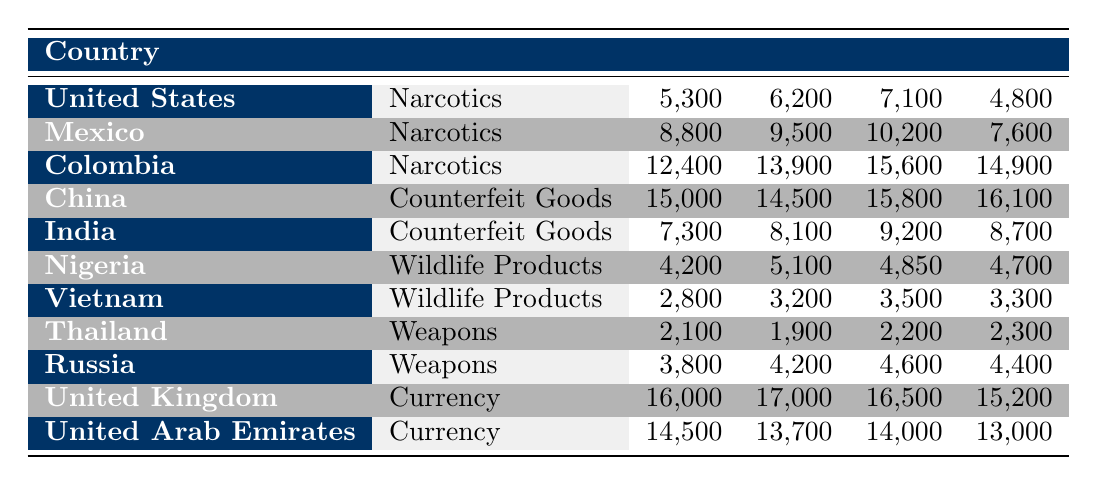What is the total amount of narcotics seized from Colombia in 2022? To find the total amount of narcotics seized from Colombia, I need to sum all quarterly values: 12400 + 13900 + 15600 + 14900 = 56800.
Answer: 56800 Which country seized the most counterfeit goods in Quarter 3? Looking at the Quarter 3 column, China has the highest value at 15800 compared to India's 9200.
Answer: China Is the amount of wildlife products seized from Vietnam greater than that from Nigeria in Quarter 2? In Quarter 2, Vietnam had 3200 and Nigeria had 5100. Since 3200 is less than 5100, the statement is false.
Answer: No What is the average amount of currency seized from the United Kingdom in 2022? To calculate the average for the United Kingdom, I sum the quarterly amounts: 16000 + 17000 + 16500 + 15200 = 64700, then divide by 4 to get 64700 / 4 = 16175.
Answer: 16175 Which type of contraband had the least amount seized in Quarter 1? I can compare the Quarter 1 values across all types: Narcotics (5,300), Counterfeit Goods (15,000), Wildlife Products (4,200), Weapons (2,100), Currency (16,000). The least is 2,100 from Weapons.
Answer: Weapons How much more narcotics were seized from Mexico compared to the United States in Quarter 4? In Quarter 4, Mexico had 7,600 and the United States had 4,800. The difference is 7,600 - 4,800 = 2,800.
Answer: 2800 Did the total amount of weapons seized from Russia exceed that of Thailand in 2022? Total for Russia is 3800 + 4200 + 4600 + 4400 = 17000, and for Thailand it is 2100 + 1900 + 2200 + 2300 = 8500. Since 17000 is greater than 8500, the statement is true.
Answer: Yes What is the total amount of wildlife products seized across both Nigeria and Vietnam for 2022? For Nigeria, the total is 4200 + 5100 + 4850 + 4700 = 18850, and for Vietnam it is 2800 + 3200 + 3500 + 3300 = 12800. Adding these gives 18850 + 12800 = 31650.
Answer: 31650 